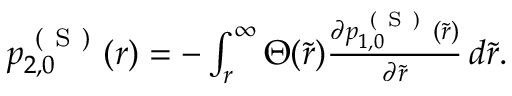<formula> <loc_0><loc_0><loc_500><loc_500>\begin{array} { r } { p _ { 2 , 0 } ^ { ( S ) } ( r ) = - \int _ { r } ^ { \infty } \Theta ( \tilde { r } ) \frac { \partial p _ { 1 , 0 } ^ { ( S ) } ( \tilde { r } ) } { \partial \tilde { r } } \, d \tilde { r } . } \end{array}</formula> 